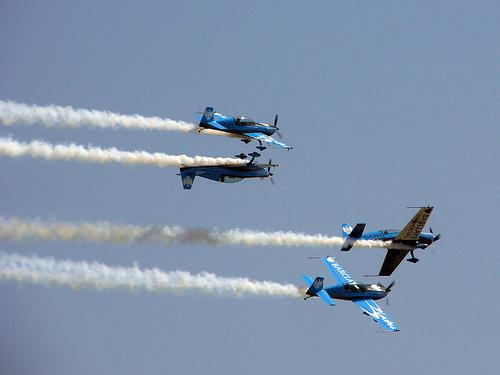Question: what color are the planes?
Choices:
A. White.
B. Grey.
C. Blue.
D. Silver.
Answer with the letter. Answer: C Question: what is coming out of the back of the planes?
Choices:
A. Smoke.
B. Parachutes.
C. Debris.
D. Contrails.
Answer with the letter. Answer: A Question: what is in the sky?
Choices:
A. Lunar eclipse.
B. Volcanic ash.
C. Planes.
D. Tornado.
Answer with the letter. Answer: C Question: where are the planes?
Choices:
A. At the bottom of the ocean in pieces.
B. On the runway.
C. On the tarmac.
D. In the sky.
Answer with the letter. Answer: D 